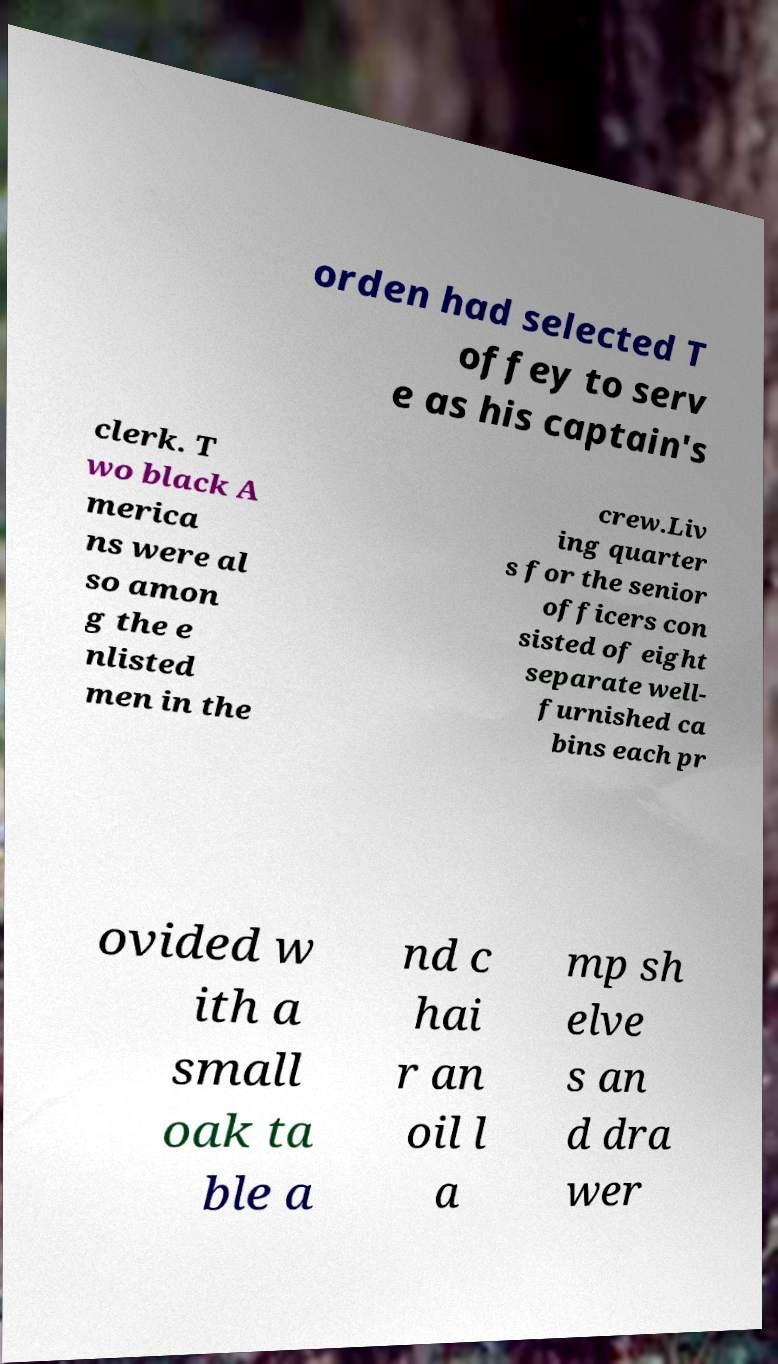Can you read and provide the text displayed in the image?This photo seems to have some interesting text. Can you extract and type it out for me? orden had selected T offey to serv e as his captain's clerk. T wo black A merica ns were al so amon g the e nlisted men in the crew.Liv ing quarter s for the senior officers con sisted of eight separate well- furnished ca bins each pr ovided w ith a small oak ta ble a nd c hai r an oil l a mp sh elve s an d dra wer 